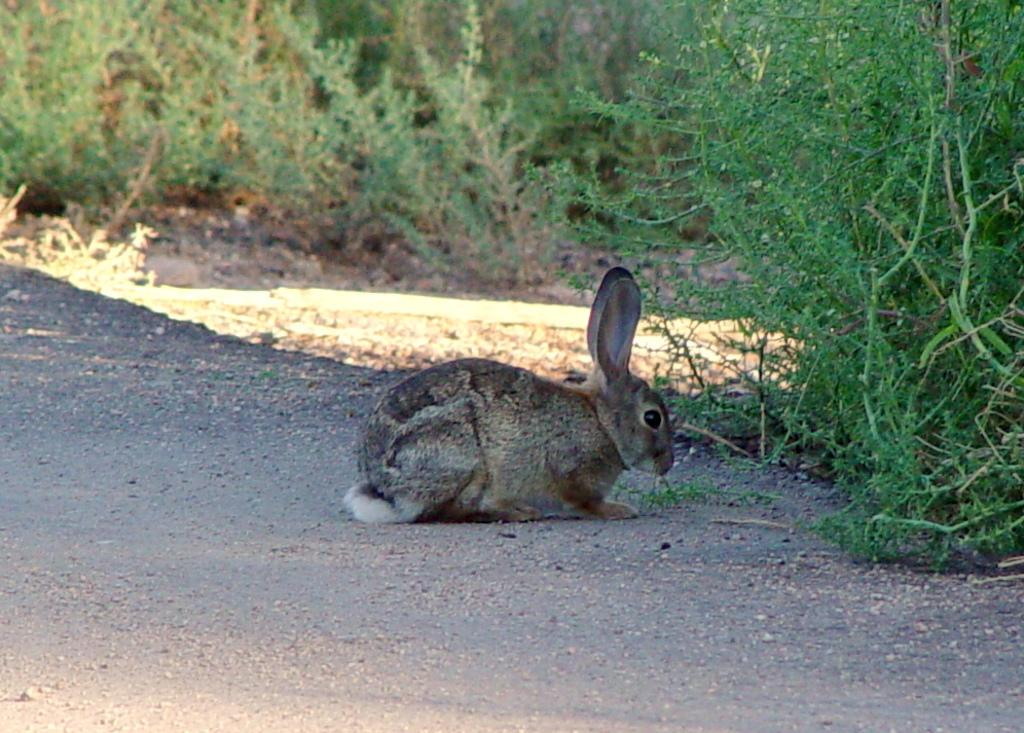What is the main subject in the center of the image? There is a rabbit in the center of the image. Where is the rabbit located? The rabbit is on the road. What can be seen in the background of the image? There are plants in the background of the image. What type of grain is being harvested in the image? There is no grain present in the image; it features a rabbit on the road with plants in the background. How many nails can be seen in the image? There are no nails present in the image. 